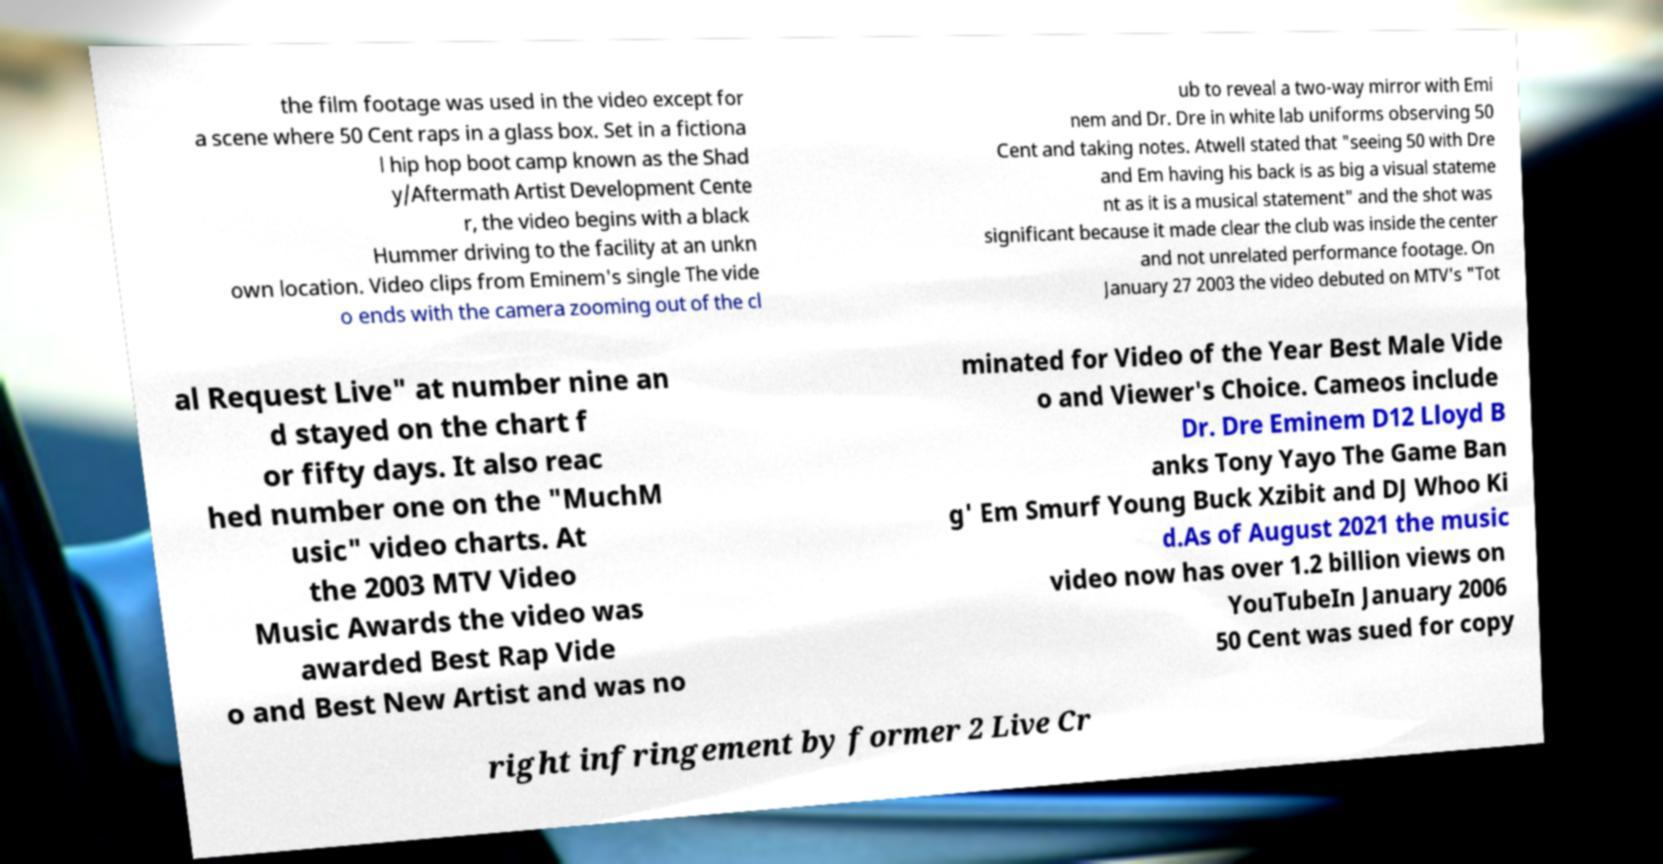Please read and relay the text visible in this image. What does it say? the film footage was used in the video except for a scene where 50 Cent raps in a glass box. Set in a fictiona l hip hop boot camp known as the Shad y/Aftermath Artist Development Cente r, the video begins with a black Hummer driving to the facility at an unkn own location. Video clips from Eminem's single The vide o ends with the camera zooming out of the cl ub to reveal a two-way mirror with Emi nem and Dr. Dre in white lab uniforms observing 50 Cent and taking notes. Atwell stated that "seeing 50 with Dre and Em having his back is as big a visual stateme nt as it is a musical statement" and the shot was significant because it made clear the club was inside the center and not unrelated performance footage. On January 27 2003 the video debuted on MTV's "Tot al Request Live" at number nine an d stayed on the chart f or fifty days. It also reac hed number one on the "MuchM usic" video charts. At the 2003 MTV Video Music Awards the video was awarded Best Rap Vide o and Best New Artist and was no minated for Video of the Year Best Male Vide o and Viewer's Choice. Cameos include Dr. Dre Eminem D12 Lloyd B anks Tony Yayo The Game Ban g' Em Smurf Young Buck Xzibit and DJ Whoo Ki d.As of August 2021 the music video now has over 1.2 billion views on YouTubeIn January 2006 50 Cent was sued for copy right infringement by former 2 Live Cr 